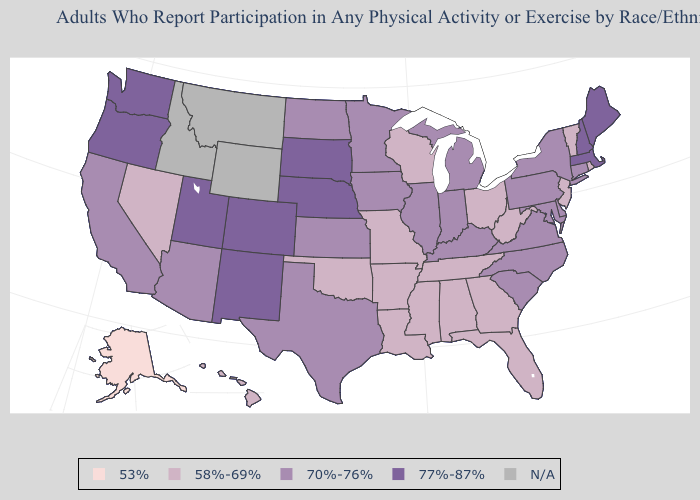Name the states that have a value in the range 77%-87%?
Short answer required. Colorado, Maine, Massachusetts, Nebraska, New Hampshire, New Mexico, Oregon, South Dakota, Utah, Washington. Among the states that border Rhode Island , does Connecticut have the lowest value?
Keep it brief. Yes. Does Texas have the lowest value in the South?
Quick response, please. No. Name the states that have a value in the range 53%?
Quick response, please. Alaska. What is the value of Illinois?
Answer briefly. 70%-76%. How many symbols are there in the legend?
Keep it brief. 5. Which states have the lowest value in the USA?
Concise answer only. Alaska. What is the highest value in the USA?
Concise answer only. 77%-87%. What is the value of Pennsylvania?
Answer briefly. 70%-76%. What is the value of Texas?
Give a very brief answer. 70%-76%. Is the legend a continuous bar?
Give a very brief answer. No. Does Alaska have the lowest value in the USA?
Concise answer only. Yes. Does Hawaii have the lowest value in the USA?
Concise answer only. No. 